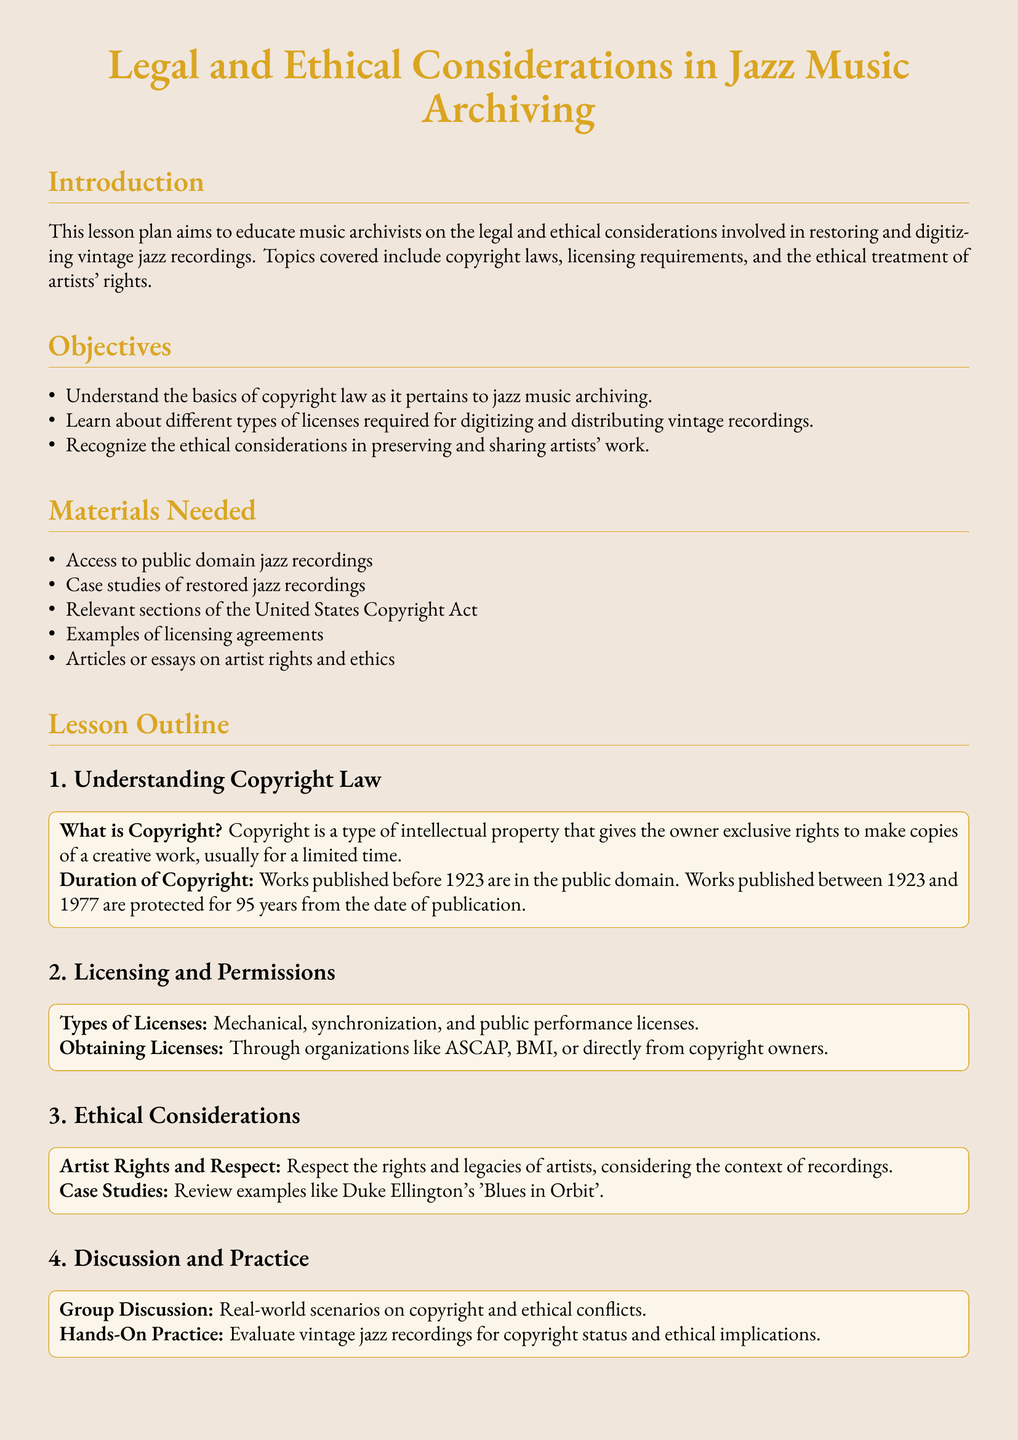What is the main topic of the lesson plan? The lesson plan focuses on the legal and ethical considerations in jazz music archiving.
Answer: Legal and Ethical Considerations in Jazz Music Archiving What year does the copyright protection end for works published in 1970? Copyright protection lasts for 95 years from the date of publication for works published between 1923 and 1977, ending in 2065 for 1970.
Answer: 2065 What type of additional materials are listed? The lesson plan includes various materials necessary for understanding the subject matter covered in the lesson.
Answer: Access to public domain jazz recordings What specific type of licenses are mentioned? The document mentions three types of licenses required for duplicating and distributing jazz recordings.
Answer: Mechanical, synchronization, and public performance licenses Which artist's work is outlined in the case studies? The case studies focus on a significant artist in jazz and their famous compositions.
Answer: Duke Ellington's 'Blues in Orbit' How many objectives are outlined in the lesson? The lesson plan clearly articulates objectives the participants should achieve by the end of the lesson.
Answer: Three What is emphasized in the ethical considerations section? The lesson emphasizes the importance of respecting the rights and legacies of the artists involved in jazz music.
Answer: Artist Rights and Respect What type of activity is included for hands-on practice? The lesson closes with an exercise designed to give participants practical experience related to the lesson objectives.
Answer: Evaluate vintage jazz recordings for copyright status What is the formatting color used for headings? The headings in the document are designed with a specific hue that is characteristic of the document's theme.
Answer: jazzgold 